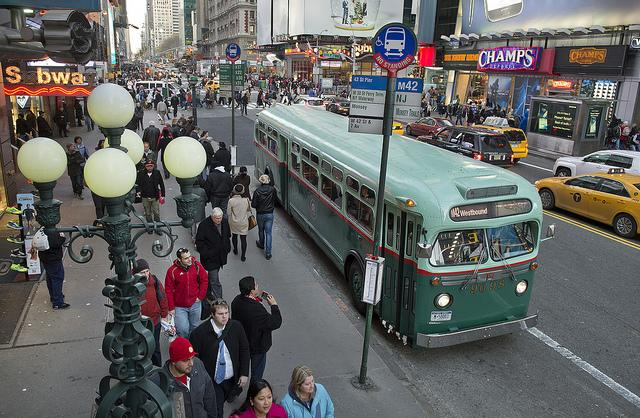Why are only the letters SBwa visible on that sign? Please explain your reasoning. broken bulbs. The other letters are visible, but they aren't lit up. 